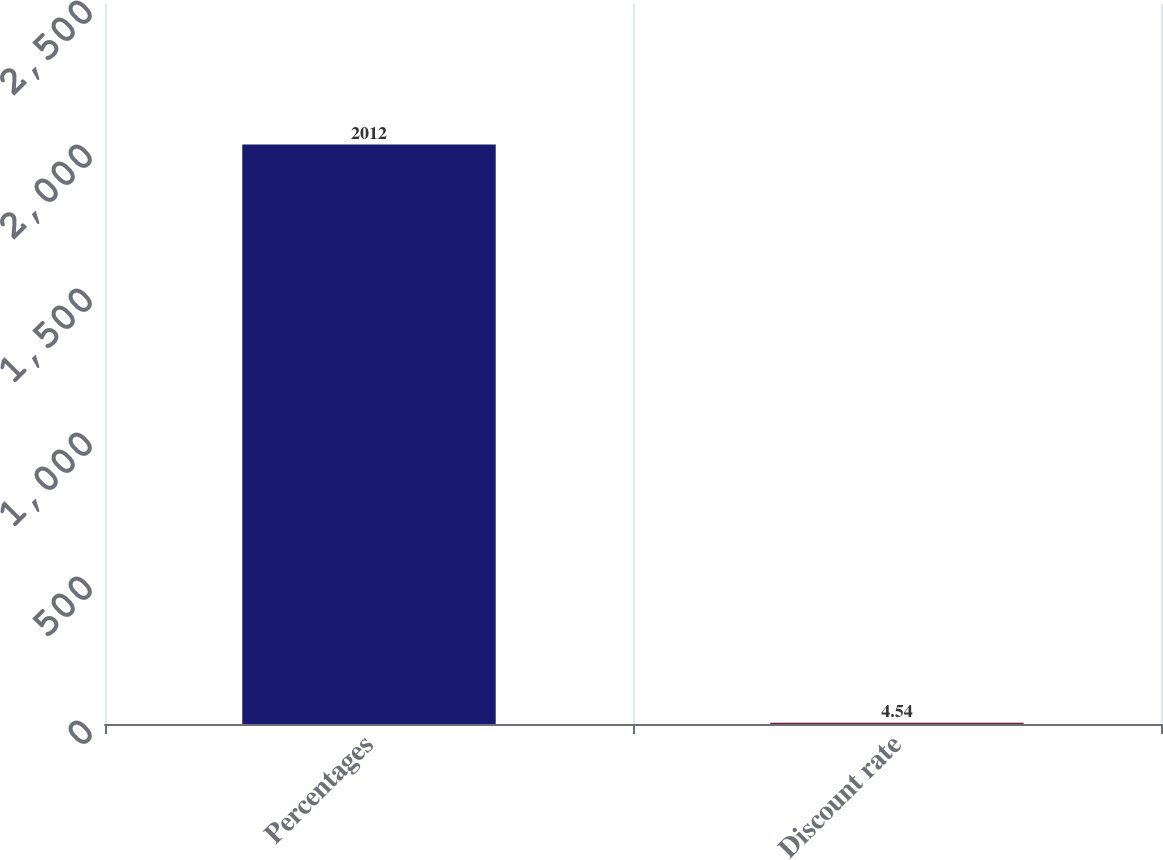<chart> <loc_0><loc_0><loc_500><loc_500><bar_chart><fcel>Percentages<fcel>Discount rate<nl><fcel>2012<fcel>4.54<nl></chart> 